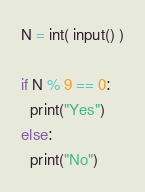<code> <loc_0><loc_0><loc_500><loc_500><_Python_>N = int( input() )

if N % 9 == 0:
  print("Yes")
else:
  print("No")
</code> 